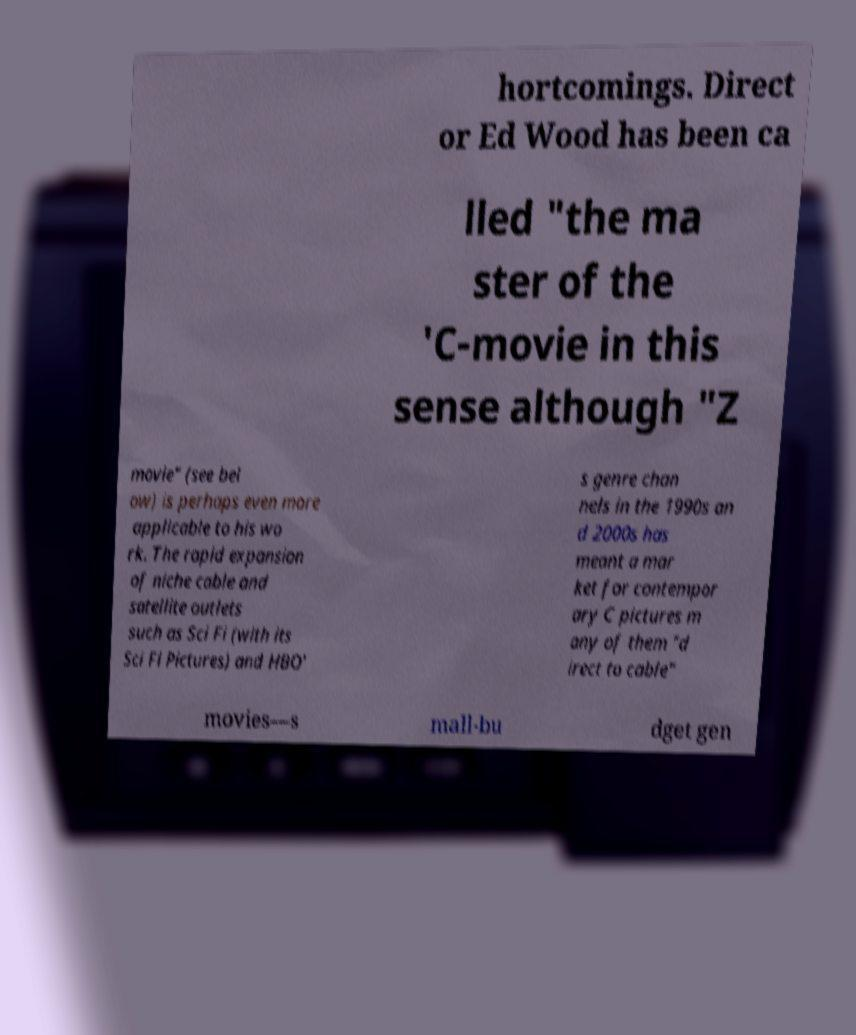For documentation purposes, I need the text within this image transcribed. Could you provide that? hortcomings. Direct or Ed Wood has been ca lled "the ma ster of the 'C-movie in this sense although "Z movie" (see bel ow) is perhaps even more applicable to his wo rk. The rapid expansion of niche cable and satellite outlets such as Sci Fi (with its Sci Fi Pictures) and HBO' s genre chan nels in the 1990s an d 2000s has meant a mar ket for contempor ary C pictures m any of them "d irect to cable" movies—s mall-bu dget gen 